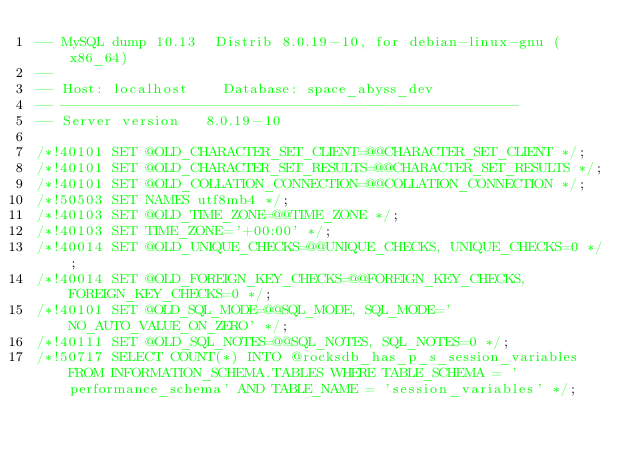<code> <loc_0><loc_0><loc_500><loc_500><_SQL_>-- MySQL dump 10.13  Distrib 8.0.19-10, for debian-linux-gnu (x86_64)
--
-- Host: localhost    Database: space_abyss_dev
-- ------------------------------------------------------
-- Server version	8.0.19-10

/*!40101 SET @OLD_CHARACTER_SET_CLIENT=@@CHARACTER_SET_CLIENT */;
/*!40101 SET @OLD_CHARACTER_SET_RESULTS=@@CHARACTER_SET_RESULTS */;
/*!40101 SET @OLD_COLLATION_CONNECTION=@@COLLATION_CONNECTION */;
/*!50503 SET NAMES utf8mb4 */;
/*!40103 SET @OLD_TIME_ZONE=@@TIME_ZONE */;
/*!40103 SET TIME_ZONE='+00:00' */;
/*!40014 SET @OLD_UNIQUE_CHECKS=@@UNIQUE_CHECKS, UNIQUE_CHECKS=0 */;
/*!40014 SET @OLD_FOREIGN_KEY_CHECKS=@@FOREIGN_KEY_CHECKS, FOREIGN_KEY_CHECKS=0 */;
/*!40101 SET @OLD_SQL_MODE=@@SQL_MODE, SQL_MODE='NO_AUTO_VALUE_ON_ZERO' */;
/*!40111 SET @OLD_SQL_NOTES=@@SQL_NOTES, SQL_NOTES=0 */;
/*!50717 SELECT COUNT(*) INTO @rocksdb_has_p_s_session_variables FROM INFORMATION_SCHEMA.TABLES WHERE TABLE_SCHEMA = 'performance_schema' AND TABLE_NAME = 'session_variables' */;</code> 